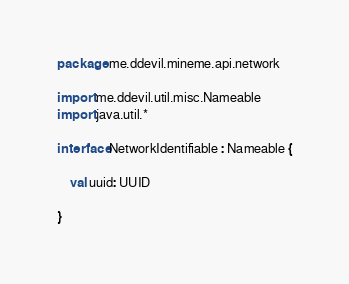<code> <loc_0><loc_0><loc_500><loc_500><_Kotlin_>package me.ddevil.mineme.api.network

import me.ddevil.util.misc.Nameable
import java.util.*

interface NetworkIdentifiable : Nameable {

    val uuid: UUID

}</code> 